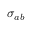<formula> <loc_0><loc_0><loc_500><loc_500>\sigma _ { a b }</formula> 